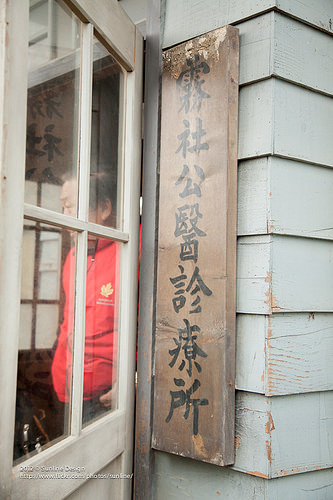<image>
Can you confirm if the man is on the door? No. The man is not positioned on the door. They may be near each other, but the man is not supported by or resting on top of the door. 